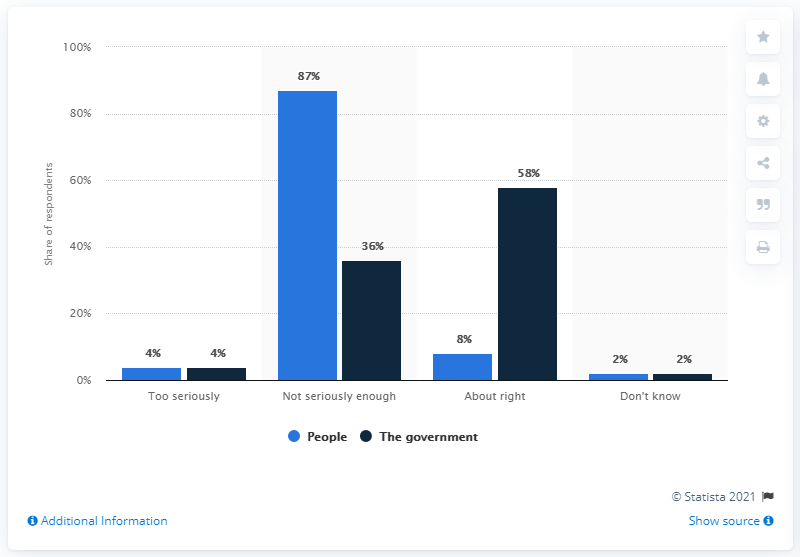Draw attention to some important aspects in this diagram. According to a recent survey, 87% of the British population felt that the response to the COVID-19 pandemic was not serious enough. 